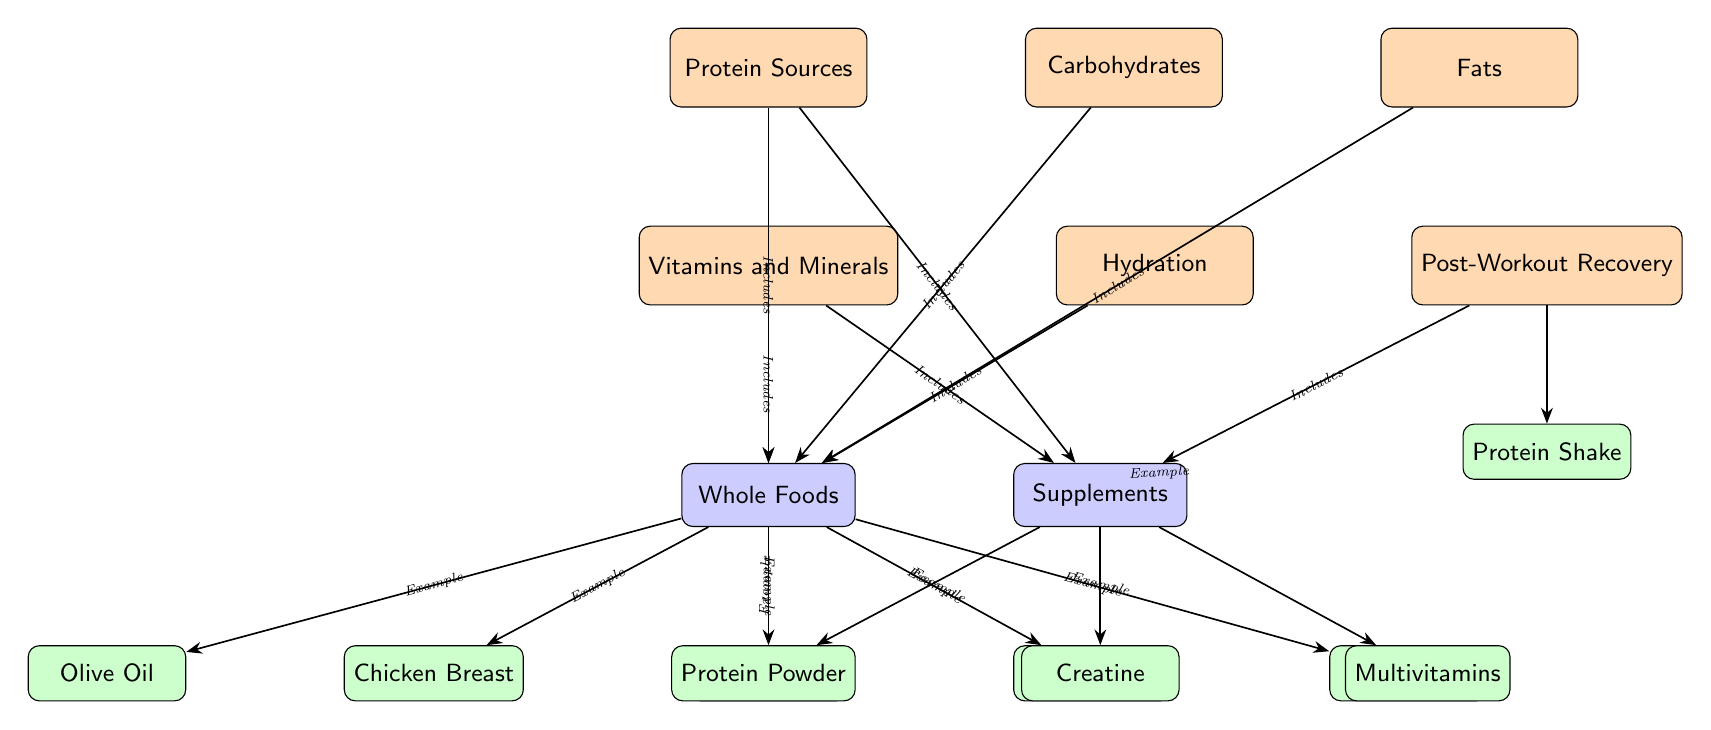What is one example of a protein source in the diagram? The diagram includes chicken breast as an example of a protein source within the "Whole Foods" category under "Protein Sources."
Answer: Chicken Breast How many subcategories are listed under "Vitamins and Minerals"? There are two subcategories listed under "Vitamins and Minerals": Whole Foods and Supplements.
Answer: 2 Which item is directly linked to the "Post-Workout Recovery" category? The diagram indicates that the "Protein Shake" is linked directly to the "Post-Workout Recovery" category as an example.
Answer: Protein Shake What connects the "Vitamins and Minerals" category to "Whole Foods"? The connection between "Vitamins and Minerals" and "Whole Foods" is established by the label "Includes," indicating that various whole foods contribute to vitamin and mineral intake.
Answer: Includes Which supplement is associated with muscle recovery according to the diagram? The diagram shows that creatine, a type of supplement, is typically associated with muscle recovery, as it falls under the "Supplements" category.
Answer: Creatine Is water classified as a food source or a hydration source in the diagram? Water is classified under the "Hydration" category, indicating its role as a source for hydration rather than food.
Answer: Hydration How many types of carbs are shown in the diagram? The diagram does not specify any distinct items listed under the "Carbohydrates" category, indicating that it does not focus on types of carbohydrates.
Answer: 0 What type of oil is mentioned in the "Whole Foods" category? The type of oil mentioned in the "Whole Foods" category is Olive Oil, indicating its classification as a fat source.
Answer: Olive Oil Which nodes are directly connected to the "Supplements" node? The "Supplements" node is directly connected to three items: Protein Powder, Creatine, and Multivitamins, highlighting various supplement options available.
Answer: Protein Powder, Creatine, Multivitamins 